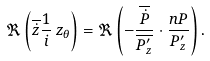<formula> <loc_0><loc_0><loc_500><loc_500>\Re \left ( \overline { \dot { z } } \frac { 1 } { i } \, z _ { \theta } \right ) = \Re \left ( - \frac { \overline { \dot { P } } } { \overline { P ^ { \prime } _ { z } } } \cdot \frac { n P } { P ^ { \prime } _ { z } } \right ) .</formula> 